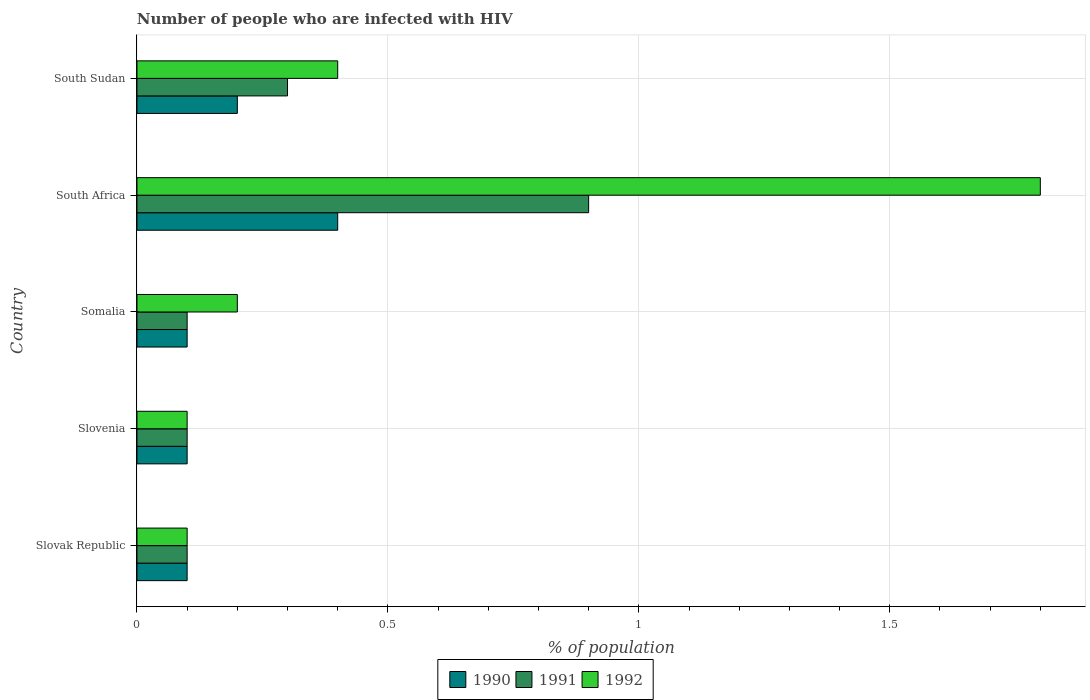How many different coloured bars are there?
Your answer should be compact. 3. Are the number of bars per tick equal to the number of legend labels?
Your response must be concise. Yes. How many bars are there on the 5th tick from the top?
Ensure brevity in your answer.  3. How many bars are there on the 5th tick from the bottom?
Your response must be concise. 3. What is the label of the 2nd group of bars from the top?
Your answer should be compact. South Africa. What is the percentage of HIV infected population in in 1991 in South Africa?
Give a very brief answer. 0.9. Across all countries, what is the maximum percentage of HIV infected population in in 1992?
Your answer should be very brief. 1.8. In which country was the percentage of HIV infected population in in 1992 maximum?
Your response must be concise. South Africa. In which country was the percentage of HIV infected population in in 1992 minimum?
Make the answer very short. Slovak Republic. What is the total percentage of HIV infected population in in 1990 in the graph?
Keep it short and to the point. 0.9. What is the difference between the percentage of HIV infected population in in 1991 in Slovak Republic and the percentage of HIV infected population in in 1990 in Somalia?
Your response must be concise. 0. What is the average percentage of HIV infected population in in 1990 per country?
Offer a very short reply. 0.18. What is the difference between the percentage of HIV infected population in in 1991 and percentage of HIV infected population in in 1990 in South Sudan?
Provide a succinct answer. 0.1. Is the percentage of HIV infected population in in 1990 in South Africa less than that in South Sudan?
Your response must be concise. No. What is the difference between the highest and the second highest percentage of HIV infected population in in 1990?
Offer a very short reply. 0.2. Is the sum of the percentage of HIV infected population in in 1992 in Slovak Republic and Slovenia greater than the maximum percentage of HIV infected population in in 1990 across all countries?
Your response must be concise. No. Is it the case that in every country, the sum of the percentage of HIV infected population in in 1991 and percentage of HIV infected population in in 1990 is greater than the percentage of HIV infected population in in 1992?
Your answer should be very brief. No. Does the graph contain grids?
Offer a very short reply. Yes. Where does the legend appear in the graph?
Offer a very short reply. Bottom center. How many legend labels are there?
Make the answer very short. 3. How are the legend labels stacked?
Provide a succinct answer. Horizontal. What is the title of the graph?
Your answer should be compact. Number of people who are infected with HIV. What is the label or title of the X-axis?
Ensure brevity in your answer.  % of population. What is the % of population of 1990 in Slovenia?
Provide a succinct answer. 0.1. What is the % of population in 1992 in Slovenia?
Keep it short and to the point. 0.1. What is the % of population in 1991 in Somalia?
Make the answer very short. 0.1. What is the % of population of 1991 in South Africa?
Keep it short and to the point. 0.9. What is the % of population of 1990 in South Sudan?
Provide a succinct answer. 0.2. What is the % of population of 1991 in South Sudan?
Your answer should be very brief. 0.3. What is the % of population in 1992 in South Sudan?
Provide a succinct answer. 0.4. Across all countries, what is the maximum % of population in 1990?
Make the answer very short. 0.4. Across all countries, what is the maximum % of population of 1992?
Provide a short and direct response. 1.8. Across all countries, what is the minimum % of population of 1991?
Make the answer very short. 0.1. What is the total % of population of 1990 in the graph?
Ensure brevity in your answer.  0.9. What is the total % of population in 1991 in the graph?
Offer a very short reply. 1.5. What is the difference between the % of population in 1990 in Slovak Republic and that in Somalia?
Keep it short and to the point. 0. What is the difference between the % of population in 1990 in Slovak Republic and that in South Africa?
Offer a very short reply. -0.3. What is the difference between the % of population of 1992 in Slovak Republic and that in South Africa?
Offer a very short reply. -1.7. What is the difference between the % of population in 1991 in Slovak Republic and that in South Sudan?
Your answer should be compact. -0.2. What is the difference between the % of population of 1990 in Slovenia and that in Somalia?
Provide a succinct answer. 0. What is the difference between the % of population in 1992 in Slovenia and that in South Africa?
Your answer should be compact. -1.7. What is the difference between the % of population of 1991 in Slovenia and that in South Sudan?
Give a very brief answer. -0.2. What is the difference between the % of population of 1992 in Slovenia and that in South Sudan?
Ensure brevity in your answer.  -0.3. What is the difference between the % of population in 1990 in Somalia and that in South Sudan?
Give a very brief answer. -0.1. What is the difference between the % of population of 1990 in South Africa and that in South Sudan?
Ensure brevity in your answer.  0.2. What is the difference between the % of population in 1990 in Slovak Republic and the % of population in 1991 in Slovenia?
Offer a terse response. 0. What is the difference between the % of population in 1990 in Slovak Republic and the % of population in 1992 in Slovenia?
Your answer should be very brief. 0. What is the difference between the % of population in 1991 in Slovak Republic and the % of population in 1992 in Slovenia?
Make the answer very short. 0. What is the difference between the % of population of 1990 in Slovak Republic and the % of population of 1992 in Somalia?
Keep it short and to the point. -0.1. What is the difference between the % of population in 1991 in Slovak Republic and the % of population in 1992 in Somalia?
Your answer should be compact. -0.1. What is the difference between the % of population in 1990 in Slovak Republic and the % of population in 1991 in South Africa?
Ensure brevity in your answer.  -0.8. What is the difference between the % of population of 1990 in Slovak Republic and the % of population of 1992 in South Africa?
Your response must be concise. -1.7. What is the difference between the % of population in 1990 in Slovak Republic and the % of population in 1991 in South Sudan?
Your answer should be compact. -0.2. What is the difference between the % of population of 1990 in Slovenia and the % of population of 1992 in Somalia?
Your response must be concise. -0.1. What is the difference between the % of population in 1990 in Slovenia and the % of population in 1991 in South Africa?
Give a very brief answer. -0.8. What is the difference between the % of population of 1990 in Slovenia and the % of population of 1992 in South Africa?
Ensure brevity in your answer.  -1.7. What is the difference between the % of population in 1991 in Slovenia and the % of population in 1992 in South Africa?
Your answer should be very brief. -1.7. What is the difference between the % of population in 1991 in Slovenia and the % of population in 1992 in South Sudan?
Make the answer very short. -0.3. What is the difference between the % of population of 1990 in Somalia and the % of population of 1991 in South Africa?
Ensure brevity in your answer.  -0.8. What is the difference between the % of population in 1990 in Somalia and the % of population in 1992 in South Africa?
Offer a terse response. -1.7. What is the difference between the % of population in 1990 in Somalia and the % of population in 1991 in South Sudan?
Offer a terse response. -0.2. What is the difference between the % of population in 1990 in Somalia and the % of population in 1992 in South Sudan?
Offer a very short reply. -0.3. What is the difference between the % of population in 1991 in Somalia and the % of population in 1992 in South Sudan?
Keep it short and to the point. -0.3. What is the difference between the % of population of 1990 in South Africa and the % of population of 1991 in South Sudan?
Provide a succinct answer. 0.1. What is the difference between the % of population of 1991 in South Africa and the % of population of 1992 in South Sudan?
Offer a very short reply. 0.5. What is the average % of population of 1990 per country?
Give a very brief answer. 0.18. What is the average % of population of 1991 per country?
Offer a terse response. 0.3. What is the average % of population of 1992 per country?
Keep it short and to the point. 0.52. What is the difference between the % of population of 1990 and % of population of 1991 in Slovak Republic?
Provide a short and direct response. 0. What is the difference between the % of population in 1990 and % of population in 1992 in Slovak Republic?
Offer a terse response. 0. What is the difference between the % of population of 1991 and % of population of 1992 in Slovak Republic?
Provide a short and direct response. 0. What is the difference between the % of population of 1990 and % of population of 1991 in Slovenia?
Your answer should be compact. 0. What is the difference between the % of population of 1991 and % of population of 1992 in Slovenia?
Give a very brief answer. 0. What is the difference between the % of population in 1990 and % of population in 1991 in Somalia?
Ensure brevity in your answer.  0. What is the difference between the % of population in 1990 and % of population in 1992 in Somalia?
Your answer should be compact. -0.1. What is the difference between the % of population of 1991 and % of population of 1992 in South Africa?
Give a very brief answer. -0.9. What is the difference between the % of population in 1990 and % of population in 1992 in South Sudan?
Provide a short and direct response. -0.2. What is the ratio of the % of population in 1991 in Slovak Republic to that in Slovenia?
Your response must be concise. 1. What is the ratio of the % of population of 1992 in Slovak Republic to that in Slovenia?
Give a very brief answer. 1. What is the ratio of the % of population in 1991 in Slovak Republic to that in South Africa?
Provide a succinct answer. 0.11. What is the ratio of the % of population of 1992 in Slovak Republic to that in South Africa?
Keep it short and to the point. 0.06. What is the ratio of the % of population in 1990 in Slovak Republic to that in South Sudan?
Your answer should be compact. 0.5. What is the ratio of the % of population of 1992 in Slovak Republic to that in South Sudan?
Provide a succinct answer. 0.25. What is the ratio of the % of population of 1990 in Slovenia to that in Somalia?
Your answer should be very brief. 1. What is the ratio of the % of population in 1991 in Slovenia to that in Somalia?
Provide a short and direct response. 1. What is the ratio of the % of population of 1992 in Slovenia to that in Somalia?
Keep it short and to the point. 0.5. What is the ratio of the % of population in 1991 in Slovenia to that in South Africa?
Offer a very short reply. 0.11. What is the ratio of the % of population in 1992 in Slovenia to that in South Africa?
Make the answer very short. 0.06. What is the ratio of the % of population in 1992 in Slovenia to that in South Sudan?
Keep it short and to the point. 0.25. What is the ratio of the % of population in 1992 in Somalia to that in South Africa?
Keep it short and to the point. 0.11. What is the ratio of the % of population of 1991 in Somalia to that in South Sudan?
Your answer should be very brief. 0.33. What is the ratio of the % of population of 1992 in Somalia to that in South Sudan?
Your answer should be very brief. 0.5. What is the ratio of the % of population in 1990 in South Africa to that in South Sudan?
Provide a succinct answer. 2. What is the difference between the highest and the second highest % of population in 1991?
Make the answer very short. 0.6. What is the difference between the highest and the second highest % of population in 1992?
Keep it short and to the point. 1.4. What is the difference between the highest and the lowest % of population in 1990?
Your answer should be compact. 0.3. 